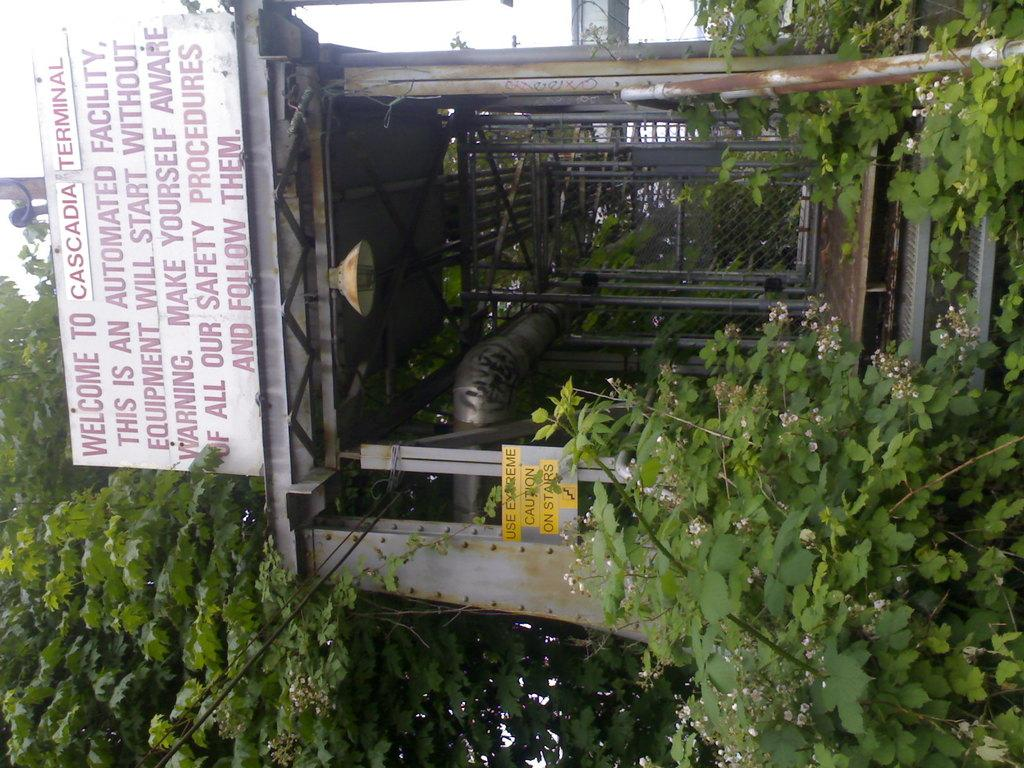Where was the image taken? The image is taken outdoors. What can be seen in the image besides the outdoor setting? There is a transformer, a board with text, many trees, and plants in the image. What type of zephyr can be seen blowing through the trees in the image? There is no mention of a zephyr in the provided facts, and the term "zephyr" typically refers to a gentle breeze, which cannot be seen. The image only shows trees and other objects, but no breeze or wind can be observed directly. 